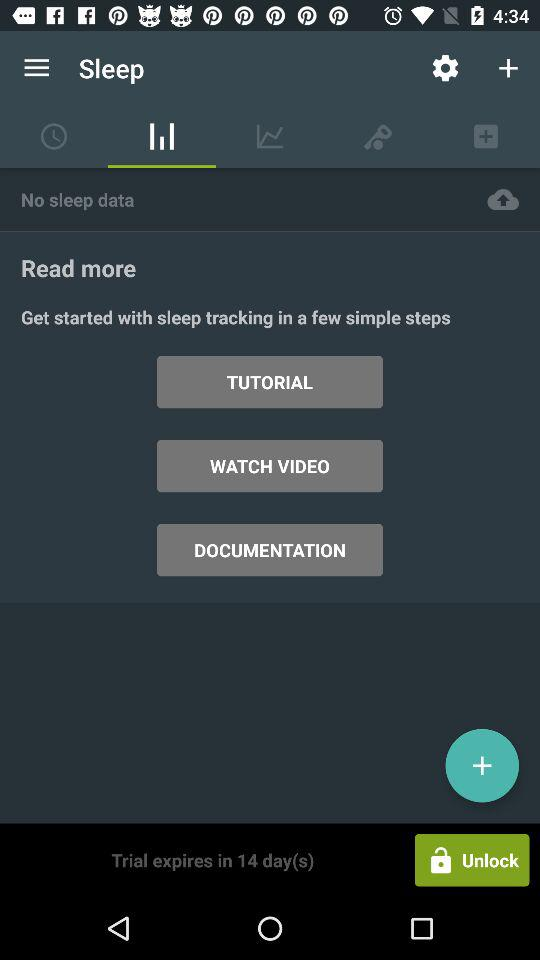How many days are left in the trial?
Answer the question using a single word or phrase. 14 